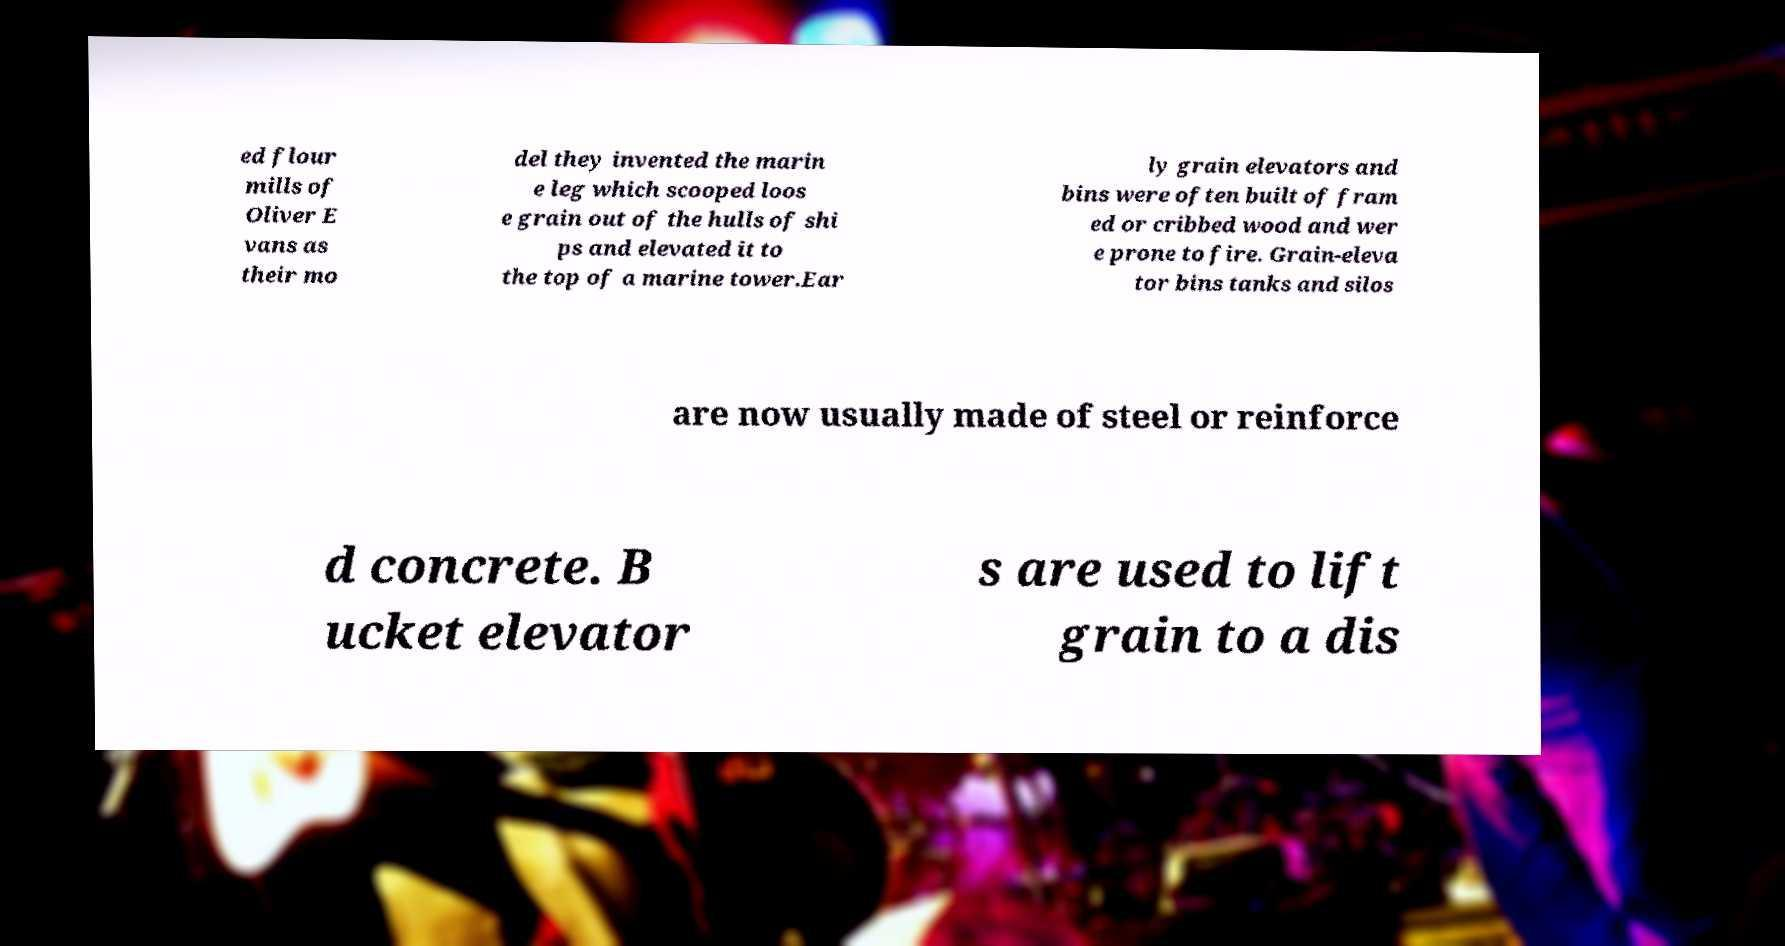What messages or text are displayed in this image? I need them in a readable, typed format. ed flour mills of Oliver E vans as their mo del they invented the marin e leg which scooped loos e grain out of the hulls of shi ps and elevated it to the top of a marine tower.Ear ly grain elevators and bins were often built of fram ed or cribbed wood and wer e prone to fire. Grain-eleva tor bins tanks and silos are now usually made of steel or reinforce d concrete. B ucket elevator s are used to lift grain to a dis 